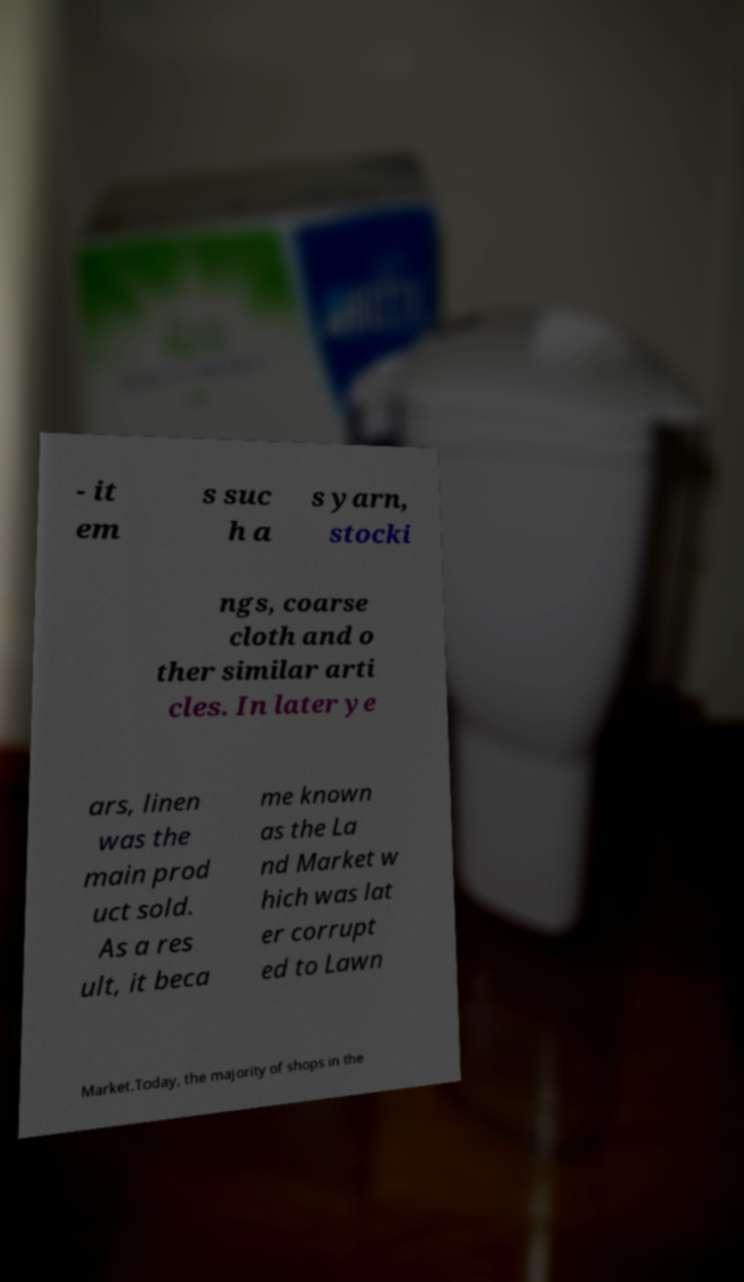Can you read and provide the text displayed in the image?This photo seems to have some interesting text. Can you extract and type it out for me? - it em s suc h a s yarn, stocki ngs, coarse cloth and o ther similar arti cles. In later ye ars, linen was the main prod uct sold. As a res ult, it beca me known as the La nd Market w hich was lat er corrupt ed to Lawn Market.Today, the majority of shops in the 